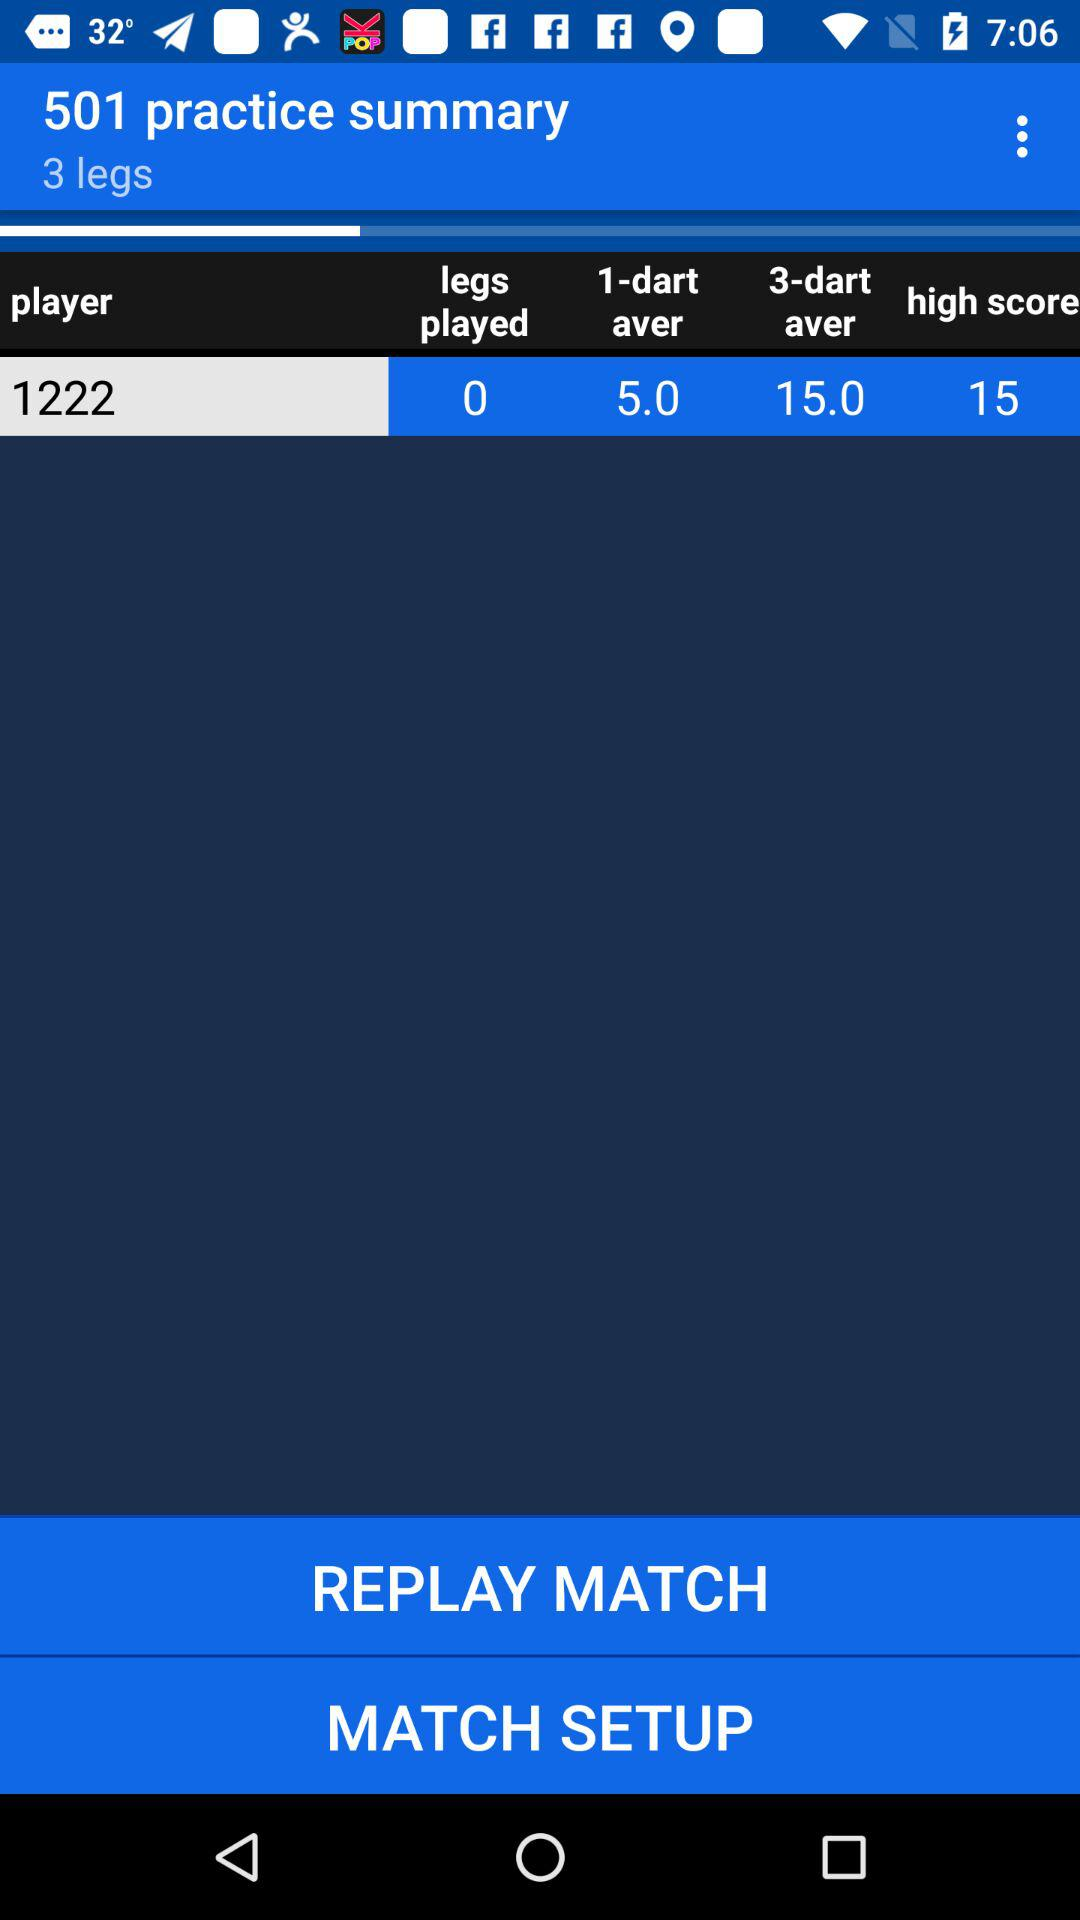Is the temperature measured in Celsius or Fahrenheit?
When the provided information is insufficient, respond with <no answer>. <no answer> 